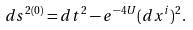<formula> <loc_0><loc_0><loc_500><loc_500>d s ^ { 2 ( 0 ) } = d t ^ { 2 } - e ^ { - 4 U } ( d x ^ { i } ) ^ { 2 } .</formula> 